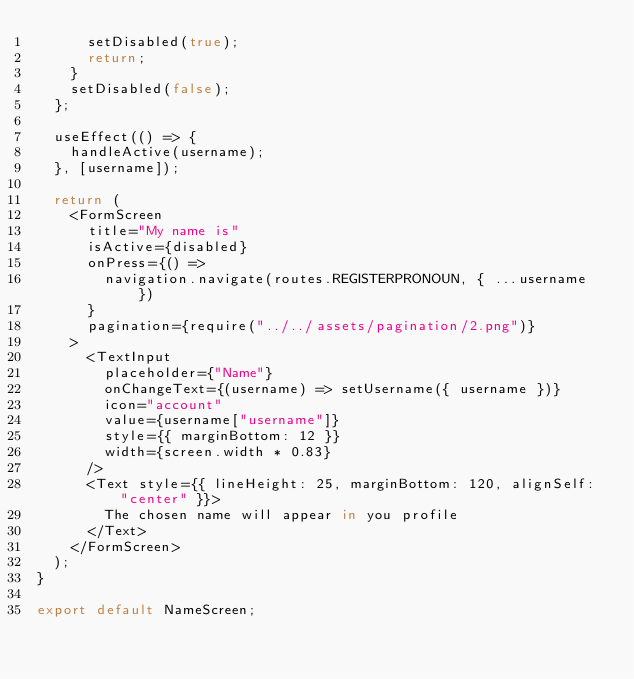<code> <loc_0><loc_0><loc_500><loc_500><_JavaScript_>      setDisabled(true);
      return;
    }
    setDisabled(false);
  };

  useEffect(() => {
    handleActive(username);
  }, [username]);

  return (
    <FormScreen
      title="My name is"
      isActive={disabled}
      onPress={() =>
        navigation.navigate(routes.REGISTERPRONOUN, { ...username })
      }
      pagination={require("../../assets/pagination/2.png")}
    >
      <TextInput
        placeholder={"Name"}
        onChangeText={(username) => setUsername({ username })}
        icon="account"
        value={username["username"]}
        style={{ marginBottom: 12 }}
        width={screen.width * 0.83}
      />
      <Text style={{ lineHeight: 25, marginBottom: 120, alignSelf: "center" }}>
        The chosen name will appear in you profile
      </Text>
    </FormScreen>
  );
}

export default NameScreen;
</code> 